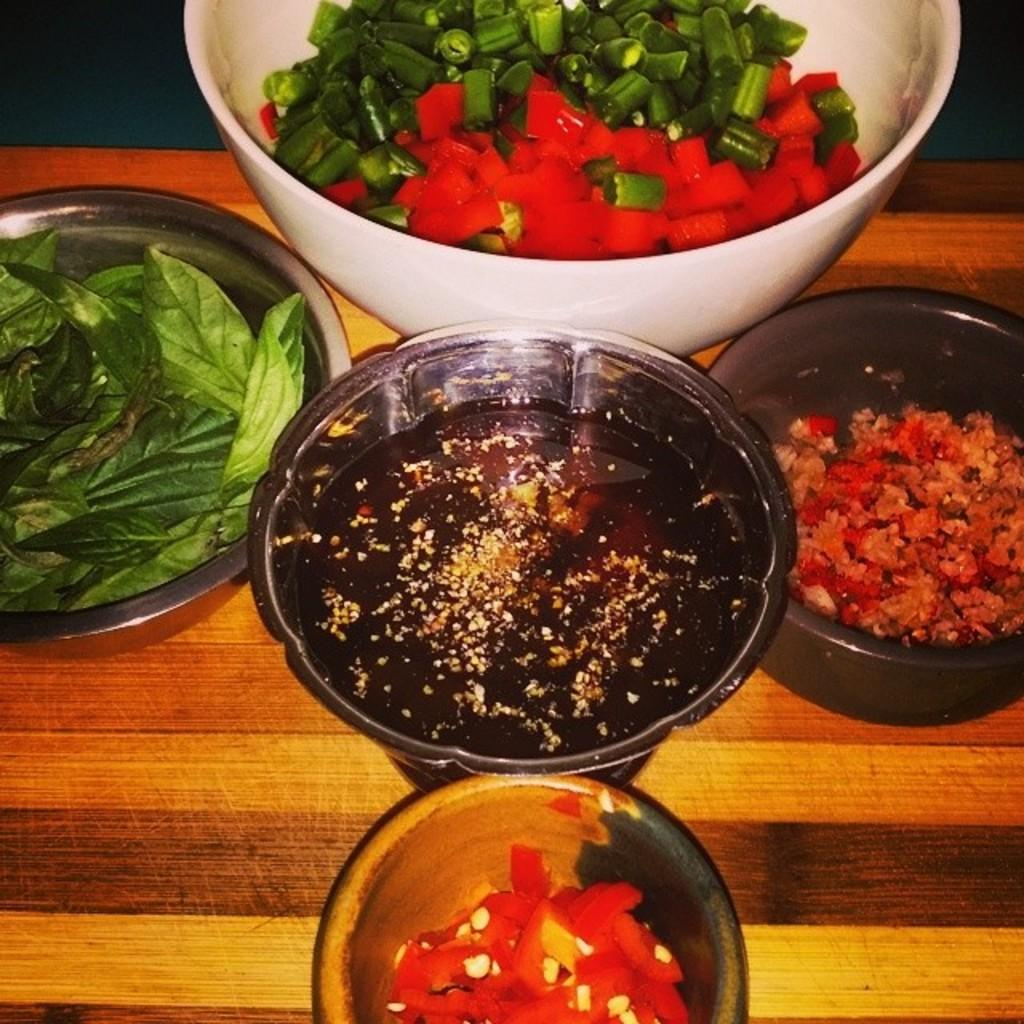How many balls are on the table in the image? There are five balls on the table in the image. What else can be seen on the table besides the balls? There are bowls with different food items in the image. Where is the hose located in the image? There is no hose present in the image. What type of tooth is visible in the image? There are no teeth visible in the image. 